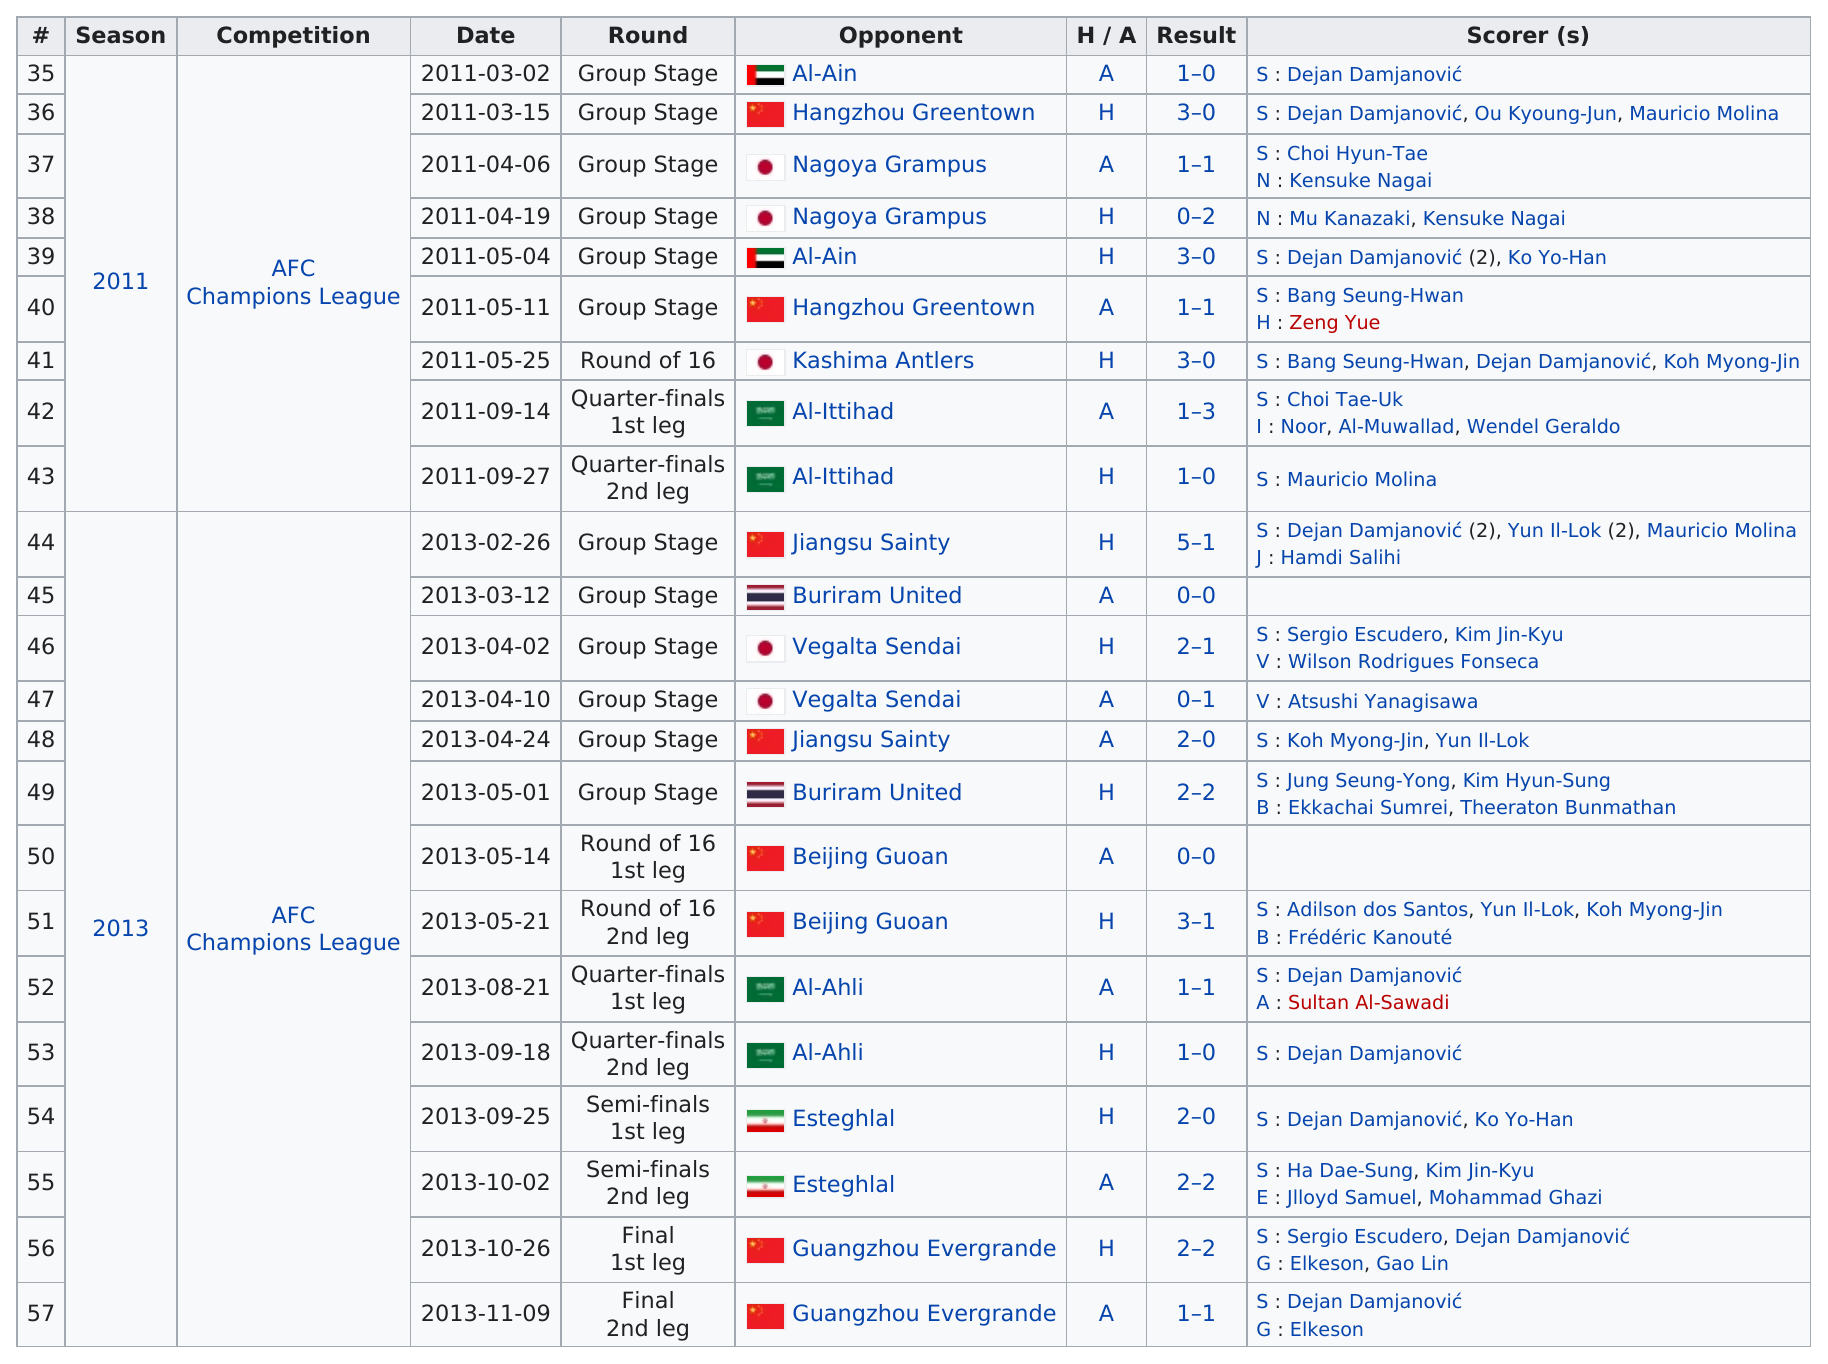Highlight a few significant elements in this photo. The last game of the 2013 season was played by Guangzhou Evergrande. In 2013, Buriram United had the least number of scorers, making it the least scoring game of that year. The total number of points scored in the game held on May 21, 2013, was 4. Dejan Damjanovic scored 5 goals in the 2011 season. The last round held in the 2011 season was the Quarter-finals 2nd leg, which took place on [insert date and location]. 